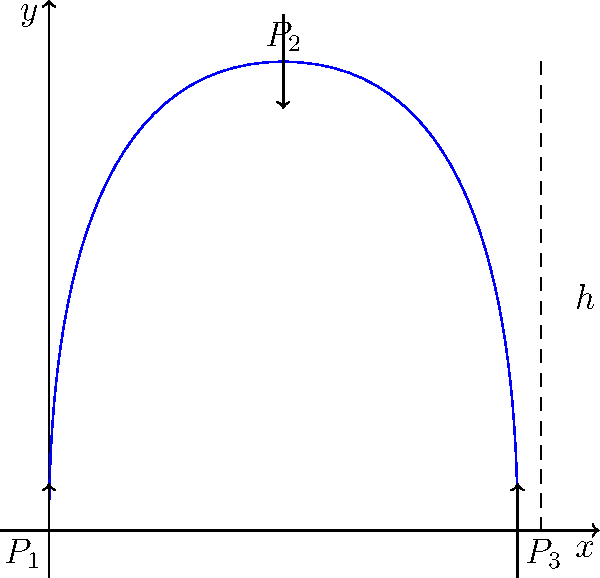During your morning walk, you notice a new water fountain in the professor's garden. The fountain shoots water upward, which then falls back down. If the height of the water jet is $h$ and the water pressure at the nozzle (bottom) is $P_1$, how does the pressure $P_2$ at the top of the water jet compare to $P_1$ and the atmospheric pressure $P_3$? Let's approach this step-by-step:

1) First, recall Bernoulli's equation for an ideal fluid:
   $$P + \frac{1}{2}\rho v^2 + \rho gh = \text{constant}$$
   where $P$ is pressure, $\rho$ is density, $v$ is velocity, $g$ is gravitational acceleration, and $h$ is height.

2) At the nozzle (point 1):
   $$P_1 + \frac{1}{2}\rho v_1^2 + \rho g(0) = \text{constant}$$

3) At the top of the jet (point 2):
   $$P_2 + \frac{1}{2}\rho v_2^2 + \rho gh = \text{constant}$$

4) At the top, the water momentarily stops (v_2 = 0) before falling back down.

5) Equating the two expressions:
   $$P_1 + \frac{1}{2}\rho v_1^2 = P_2 + \rho gh$$

6) Rearranging:
   $$P_2 = P_1 + \frac{1}{2}\rho v_1^2 - \rho gh$$

7) The term $\frac{1}{2}\rho v_1^2 - \rho gh$ is always positive (it's the energy needed to push the water up).

8) Therefore, $P_2 < P_1$

9) At the top, the water is exposed to the atmosphere, so $P_2 = P_3$ (atmospheric pressure)

10) Thus, $P_2 = P_3 < P_1$
Answer: $P_2 = P_3 < P_1$ 